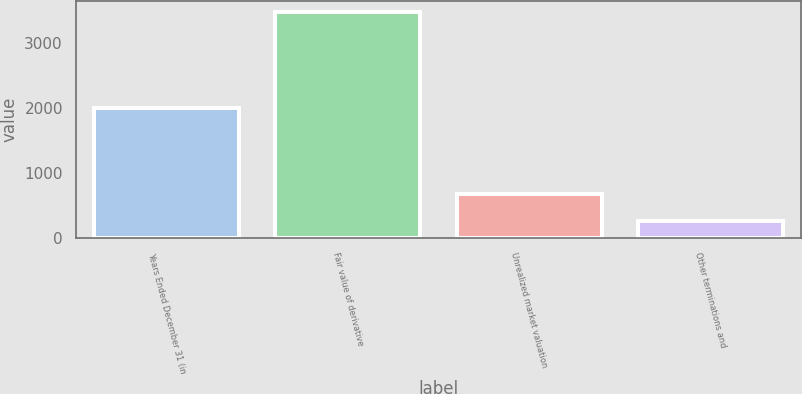Convert chart. <chart><loc_0><loc_0><loc_500><loc_500><bar_chart><fcel>Years Ended December 31 (in<fcel>Fair value of derivative<fcel>Unrealized market valuation<fcel>Other terminations and<nl><fcel>2010<fcel>3484<fcel>685.7<fcel>271<nl></chart> 